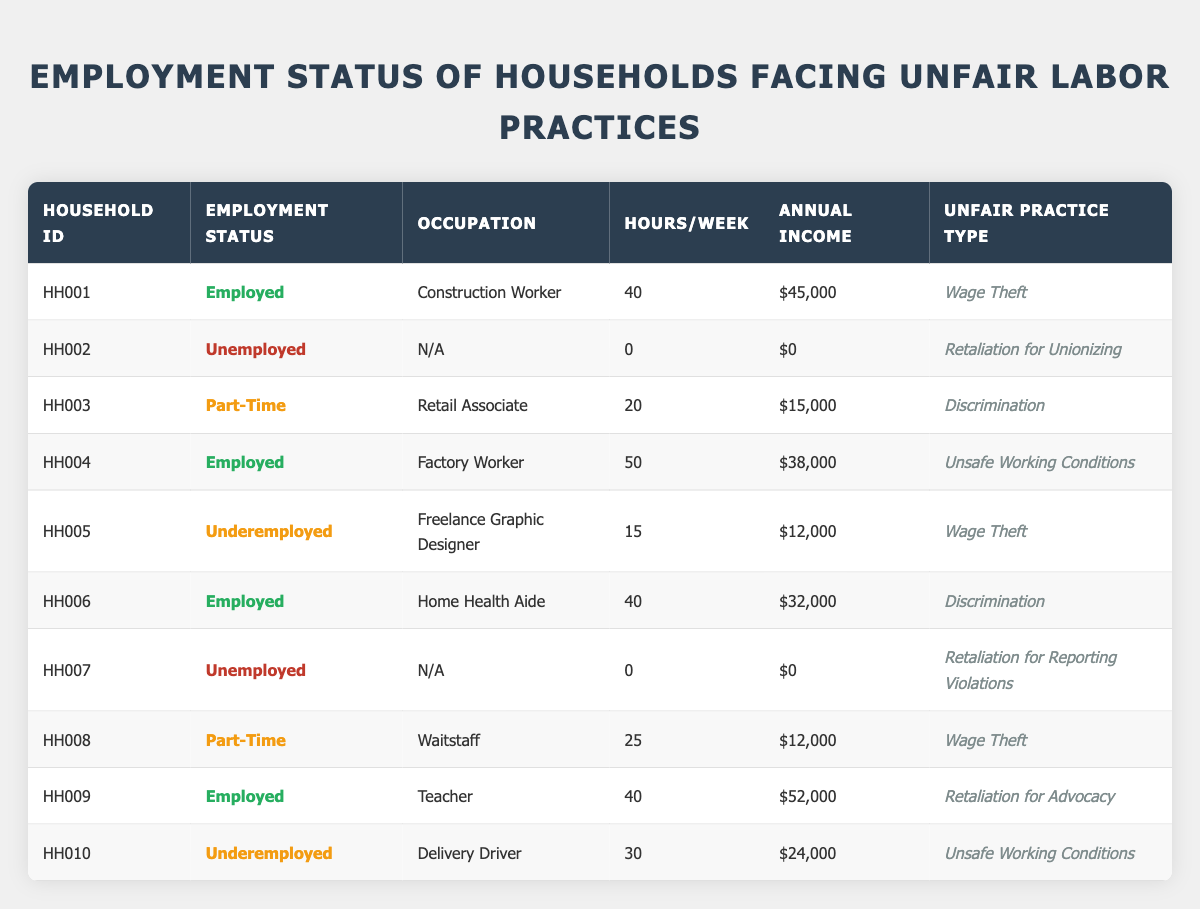What is the employment status of Household HH003? Referring to the table, the row for Household HH003 indicates that the Employment Status is "Part-Time."
Answer: Part-Time How many households are employed full-time? The table defines "Employed" as those who are employed full-time. There are three instances: HH001, HH004, and HH009. Therefore, there are 3 employed households.
Answer: 3 Which household has the highest annual income? Looking at the Annual Income column, HH009 with an income of $52,000 is the highest.
Answer: HH009 Is there any household that is unemployed? Checking the "Employment Status" column, Household HH002 and HH007 are listed as "Unemployed." Hence, the answer is yes.
Answer: Yes What is the total annual income of all households combined? Summing the annual incomes: 45000 (HH001) + 0 (HH002) + 15000 (HH003) + 38000 (HH004) + 12000 (HH005) + 32000 (HH006) + 0 (HH007) + 12000 (HH008) + 52000 (HH009) + 24000 (HH010) = 1,64000.
Answer: $164,000 What percentage of the households are part-time employees? There are two households that are part-time (HH003 and HH008). With 10 households total, the percentage is (2/10)*100 = 20%.
Answer: 20% How many hours per week does the average employed individual work? The total hours worked by employed individuals are: 40 (HH001) + 50 (HH004) + 40 (HH006) + 40 (HH009) = 170 hours. There are 4 employed individuals, so the average is 170/4 = 42.5 hours per week.
Answer: 42.5 Which unfair practice type is most commonly associated with employed individuals? Out of the employed individuals (HH001, HH004, HH006, HH009), the unfair practice types are Wage Theft (HH001), Unsafe Working Conditions (HH004), Discrimination (HH006), and Retaliation for Advocacy (HH009). Each is distinct.
Answer: All are distinct What is the average annual income for underemployed individuals in this table? The underemployed households are HH005 and HH010, with annual incomes of $12,000 and $24,000. Thus, the average is (12000 + 24000)/2 = $18,000.
Answer: $18,000 Of the households facing "Wage Theft," what is the combined annual income? The households facing Wage Theft are HH001 with $45,000, HH005 with $12,000, and HH008 with $12,000. The total is $45000 + $12000 + $12000 = $69000.
Answer: $69,000 